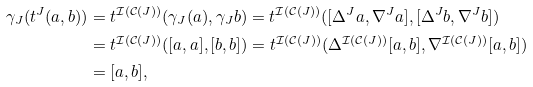Convert formula to latex. <formula><loc_0><loc_0><loc_500><loc_500>\gamma _ { J } ( t ^ { J } ( a , b ) ) & = t ^ { \mathcal { I } ( \mathcal { C } ( J ) ) } ( \gamma _ { J } ( a ) , \gamma _ { J } b ) = t ^ { \mathcal { I } ( \mathcal { C } ( J ) ) } ( [ \Delta ^ { J } a , \nabla ^ { J } a ] , [ \Delta ^ { J } b , \nabla ^ { J } b ] ) \\ & = t ^ { \mathcal { I } ( \mathcal { C } ( J ) ) } ( [ a , a ] , [ b , b ] ) = t ^ { \mathcal { I } ( \mathcal { C } ( J ) ) } ( \Delta ^ { \mathcal { I } ( \mathcal { C } ( J ) ) } [ a , b ] , \nabla ^ { \mathcal { I } ( \mathcal { C } ( J ) ) } [ a , b ] ) \\ & = [ a , b ] ,</formula> 